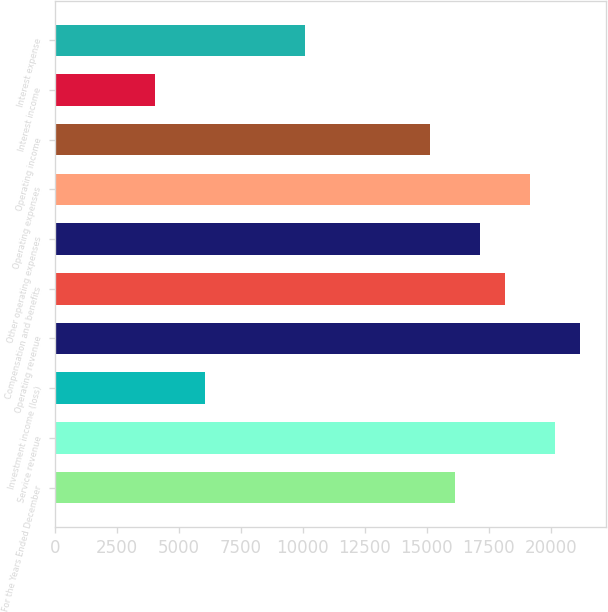<chart> <loc_0><loc_0><loc_500><loc_500><bar_chart><fcel>For the Years Ended December<fcel>Service revenue<fcel>Investment income (loss)<fcel>Operating revenue<fcel>Compensation and benefits<fcel>Other operating expenses<fcel>Operating expenses<fcel>Operating income<fcel>Interest income<fcel>Interest expense<nl><fcel>16130.9<fcel>20163.6<fcel>6049.33<fcel>21171.7<fcel>18147.2<fcel>17139.1<fcel>19155.4<fcel>15122.8<fcel>4033.01<fcel>10082<nl></chart> 